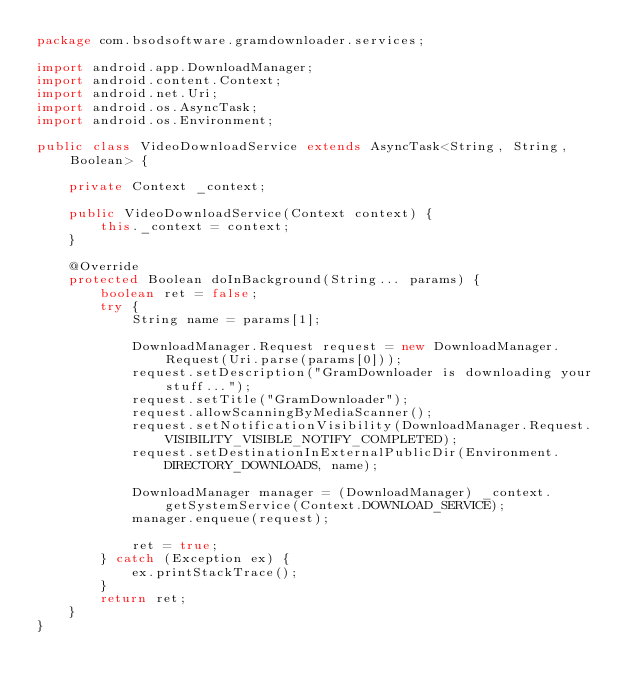Convert code to text. <code><loc_0><loc_0><loc_500><loc_500><_Java_>package com.bsodsoftware.gramdownloader.services;

import android.app.DownloadManager;
import android.content.Context;
import android.net.Uri;
import android.os.AsyncTask;
import android.os.Environment;

public class VideoDownloadService extends AsyncTask<String, String, Boolean> {

    private Context _context;

    public VideoDownloadService(Context context) {
        this._context = context;
    }

    @Override
    protected Boolean doInBackground(String... params) {
        boolean ret = false;
        try {
            String name = params[1];

            DownloadManager.Request request = new DownloadManager.Request(Uri.parse(params[0]));
            request.setDescription("GramDownloader is downloading your stuff...");
            request.setTitle("GramDownloader");
            request.allowScanningByMediaScanner();
            request.setNotificationVisibility(DownloadManager.Request.VISIBILITY_VISIBLE_NOTIFY_COMPLETED);
            request.setDestinationInExternalPublicDir(Environment.DIRECTORY_DOWNLOADS, name);

            DownloadManager manager = (DownloadManager) _context.getSystemService(Context.DOWNLOAD_SERVICE);
            manager.enqueue(request);

            ret = true;
        } catch (Exception ex) {
            ex.printStackTrace();
        }
        return ret;
    }
}
</code> 